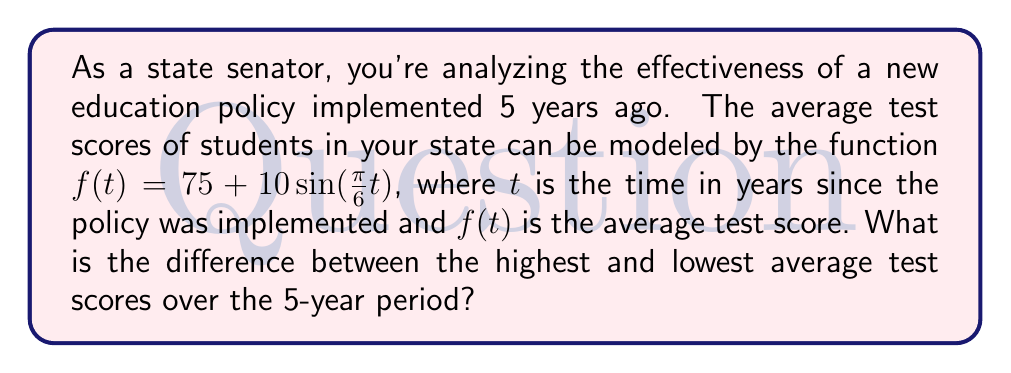What is the answer to this math problem? Let's approach this step-by-step:

1) The function given is $f(t) = 75 + 10\sin(\frac{\pi}{6}t)$

2) This is a sinusoidal function with:
   - Amplitude: 10
   - Vertical shift: 75
   - Period: $\frac{2\pi}{\frac{\pi}{6}} = 12$ years

3) The maximum value of sine is 1, and the minimum is -1. So:
   - Maximum value of $f(t) = 75 + 10(1) = 85$
   - Minimum value of $f(t) = 75 + 10(-1) = 65$

4) The difference between the highest and lowest scores is:
   $85 - 65 = 20$

5) Note: We don't need to consider the specific 5-year period because the function repeats every 12 years, so the full range of values will be achieved within any 5-year span.
Answer: 20 points 